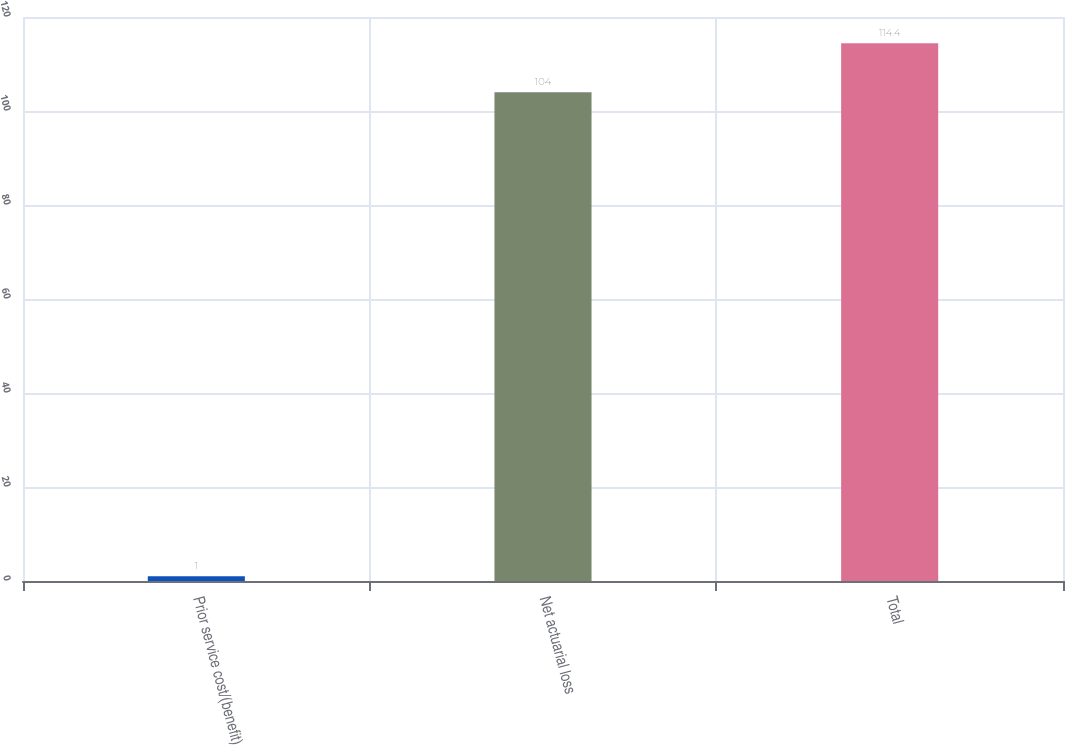Convert chart to OTSL. <chart><loc_0><loc_0><loc_500><loc_500><bar_chart><fcel>Prior service cost/(benefit)<fcel>Net actuarial loss<fcel>Total<nl><fcel>1<fcel>104<fcel>114.4<nl></chart> 